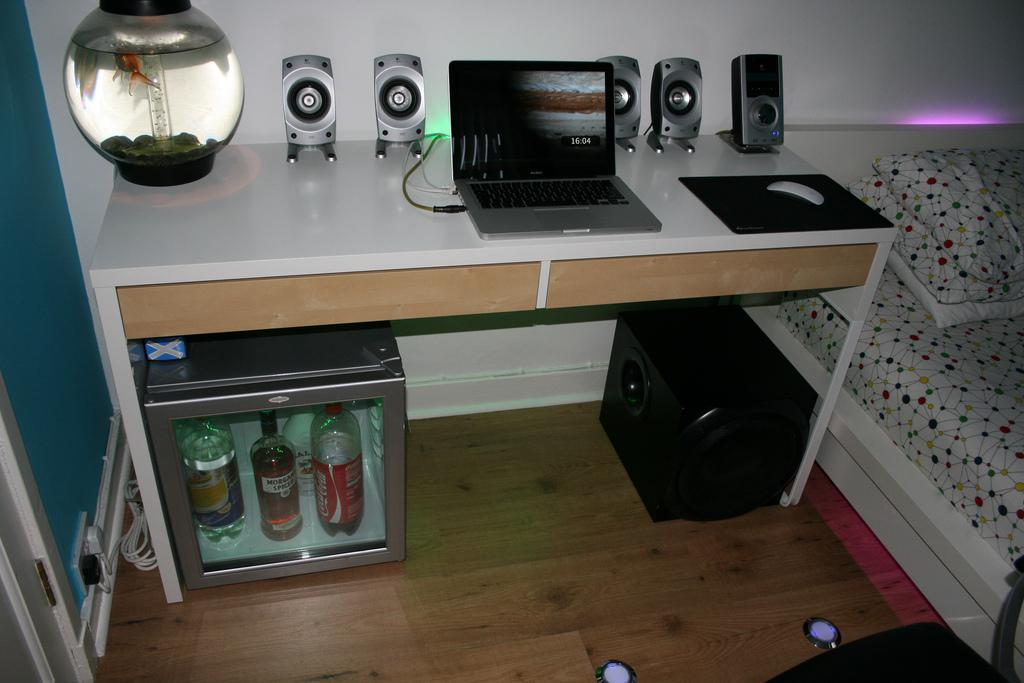Question: why is there a cooler under the desk?
Choices:
A. To keep food cold.
B. For lunch.
C. To keep the drinks cold.
D. To stop food from spoiling.
Answer with the letter. Answer: C Question: what is black under the desk?
Choices:
A. Shoes.
B. Drawers.
C. Socks.
D. Speakers.
Answer with the letter. Answer: D Question: when was this picture taken?
Choices:
A. When the room was a mess.
B. When the room was filled with people.
C. When the room was empty.
D. When the room was clean.
Answer with the letter. Answer: D Question: where is the laptop?
Choices:
A. On the table.
B. On the couch.
C. On the desk.
D. On a person's lap.
Answer with the letter. Answer: C Question: where is the small fridge located?
Choices:
A. In the kitchen.
B. In my dorm room.
C. Under the table.
D. In the garage.
Answer with the letter. Answer: C Question: what color is the light behind the headboard?
Choices:
A. White.
B. Black.
C. Red.
D. Purple.
Answer with the letter. Answer: D Question: where are the speakers and the laptop located?
Choices:
A. On top of the table.
B. On the desk.
C. In the classroom.
D. At the library.
Answer with the letter. Answer: A Question: what color are the walls?
Choices:
A. Beige.
B. Yellow.
C. Green.
D. Blue and white.
Answer with the letter. Answer: D Question: what is the table located next to?
Choices:
A. The door.
B. The couch.
C. The far corner.
D. A bed.
Answer with the letter. Answer: D Question: what material is the floor made out of?
Choices:
A. Stone.
B. Hardwood.
C. Concrete.
D. Glass.
Answer with the letter. Answer: B Question: what type of alcohol is in the fridge?
Choices:
A. Southern comfort.
B. Jack Daniels.
C. Captain Morgan.
D. Everclear.
Answer with the letter. Answer: A Question: what type of scene is this?
Choices:
A. Outdoors.
B. Indoors.
C. Crowd.
D. Landscape.
Answer with the letter. Answer: B Question: what wall is blue?
Choices:
A. The near wall.
B. The far wall.
C. The side wall.
D. The inner wall.
Answer with the letter. Answer: C Question: how many speakers are on the desk?
Choices:
A. 2.
B. 4.
C. 5.
D. 6.
Answer with the letter. Answer: C Question: what white object has colorful polka dots on it?
Choices:
A. A dress.
B. A curtain.
C. A birthday cake.
D. The bed.
Answer with the letter. Answer: D Question: where are the four silver and black speakers located?
Choices:
A. Against the back of the dresser top.
B. In the trunk of my car.
C. In the closet.
D. In the garage.
Answer with the letter. Answer: A Question: where is a bottle of rum?
Choices:
A. Back row of fridge.
B. On the shelf.
C. Near the vodka.
D. Beside the oven.
Answer with the letter. Answer: A Question: what time is on the laptop?
Choices:
A. 10:04.
B. 12:00.
C. 1:00.
D. 4:00.
Answer with the letter. Answer: A 